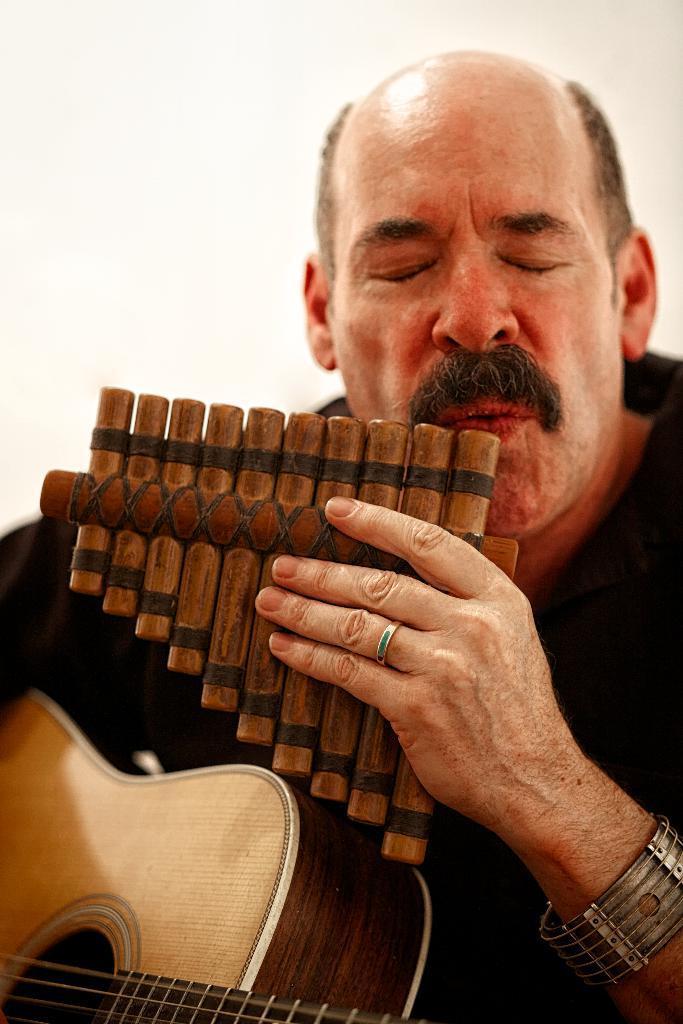In one or two sentences, can you explain what this image depicts? In the middle of the image a man is holding guitar. 